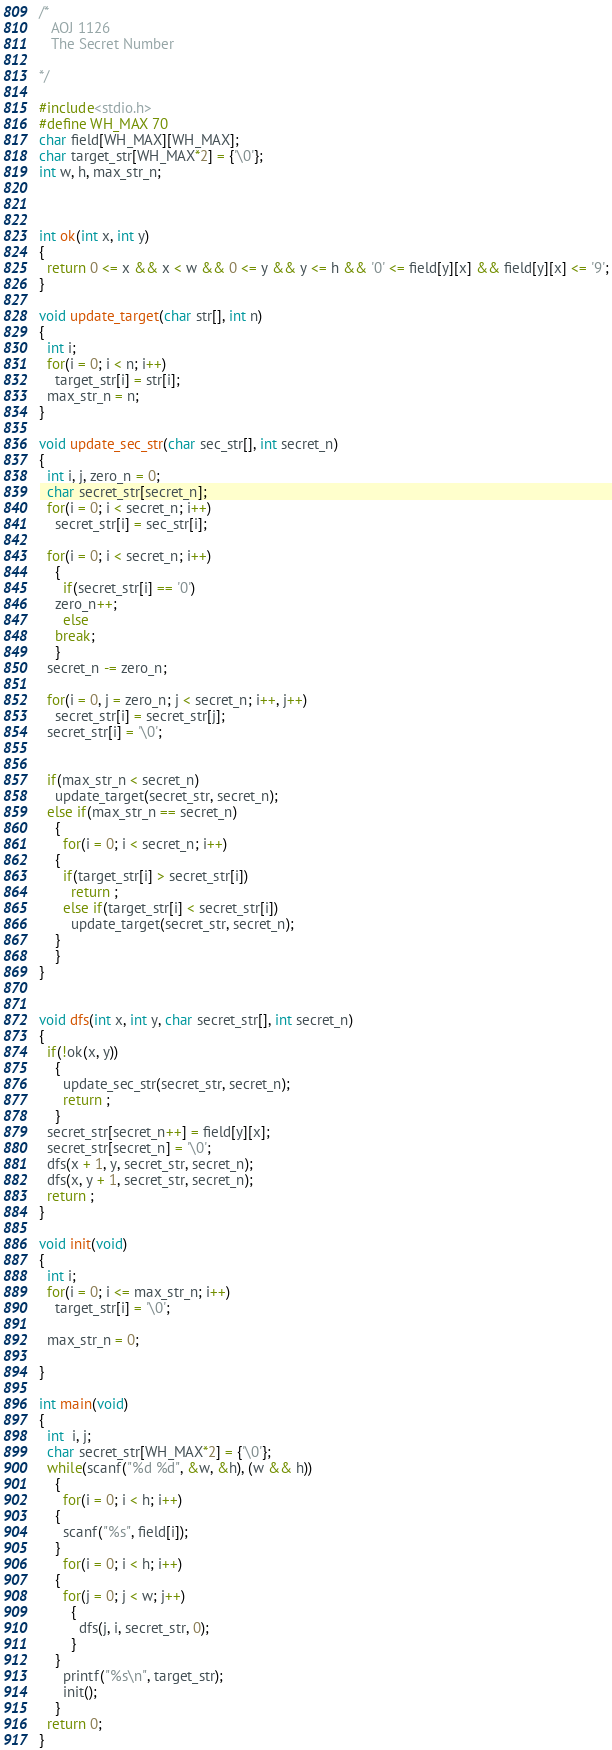<code> <loc_0><loc_0><loc_500><loc_500><_C_>/* 
   AOJ 1126
   The Secret Number

*/

#include<stdio.h>
#define WH_MAX 70
char field[WH_MAX][WH_MAX];
char target_str[WH_MAX*2] = {'\0'};
int w, h, max_str_n;



int ok(int x, int y)
{
  return 0 <= x && x < w && 0 <= y && y <= h && '0' <= field[y][x] && field[y][x] <= '9';
}

void update_target(char str[], int n)
{
  int i;
  for(i = 0; i < n; i++)
    target_str[i] = str[i];
  max_str_n = n;
}

void update_sec_str(char sec_str[], int secret_n)
{
  int i, j, zero_n = 0;
  char secret_str[secret_n];
  for(i = 0; i < secret_n; i++)
    secret_str[i] = sec_str[i];
  
  for(i = 0; i < secret_n; i++)
    {
      if(secret_str[i] == '0')
	zero_n++;
      else
	break;
    }
  secret_n -= zero_n;

  for(i = 0, j = zero_n; j < secret_n; i++, j++)
    secret_str[i] = secret_str[j];
  secret_str[i] = '\0';


  if(max_str_n < secret_n)
    update_target(secret_str, secret_n);
  else if(max_str_n == secret_n)
    {
      for(i = 0; i < secret_n; i++)
	{
	  if(target_str[i] > secret_str[i])
	    return ;
	  else if(target_str[i] < secret_str[i])
	    update_target(secret_str, secret_n);
	}
    }
}


void dfs(int x, int y, char secret_str[], int secret_n)
{
  if(!ok(x, y))
    {
      update_sec_str(secret_str, secret_n);
      return ;      
    }
  secret_str[secret_n++] = field[y][x];
  secret_str[secret_n] = '\0';
  dfs(x + 1, y, secret_str, secret_n);
  dfs(x, y + 1, secret_str, secret_n);
  return ;
}

void init(void)
{
  int i;
  for(i = 0; i <= max_str_n; i++)
    target_str[i] = '\0';

  max_str_n = 0;

}

int main(void)
{
  int  i, j;
  char secret_str[WH_MAX*2] = {'\0'};
  while(scanf("%d %d", &w, &h), (w && h))
    {
      for(i = 0; i < h; i++)
	{
	  scanf("%s", field[i]);
	}
      for(i = 0; i < h; i++)
	{
	  for(j = 0; j < w; j++)
	    {
	      dfs(j, i, secret_str, 0);
	    }
	}
      printf("%s\n", target_str);
      init();
    }
  return 0;
}</code> 